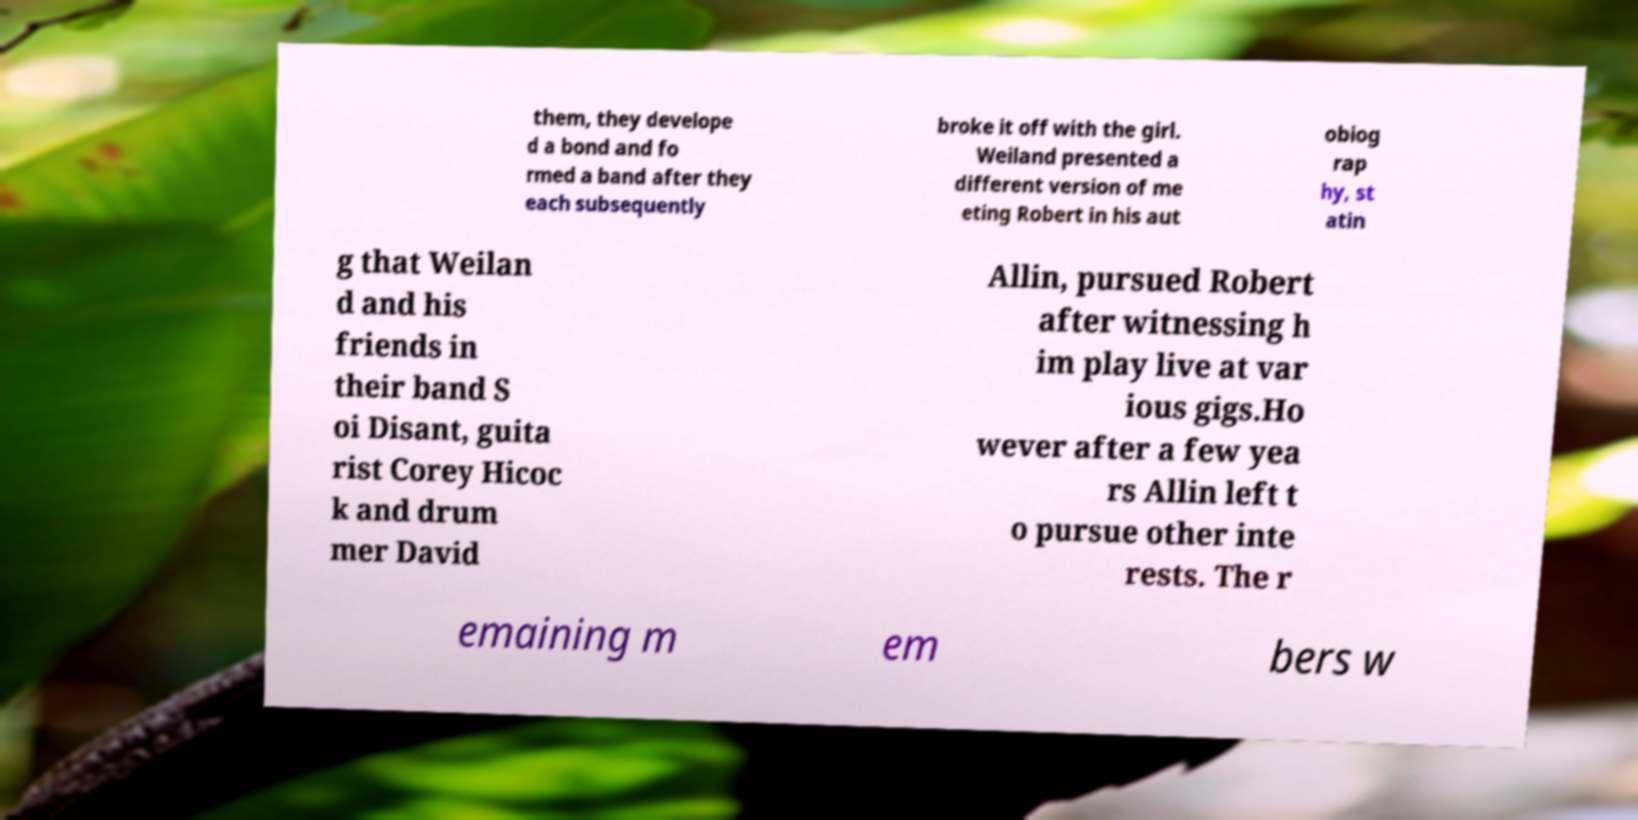There's text embedded in this image that I need extracted. Can you transcribe it verbatim? them, they develope d a bond and fo rmed a band after they each subsequently broke it off with the girl. Weiland presented a different version of me eting Robert in his aut obiog rap hy, st atin g that Weilan d and his friends in their band S oi Disant, guita rist Corey Hicoc k and drum mer David Allin, pursued Robert after witnessing h im play live at var ious gigs.Ho wever after a few yea rs Allin left t o pursue other inte rests. The r emaining m em bers w 